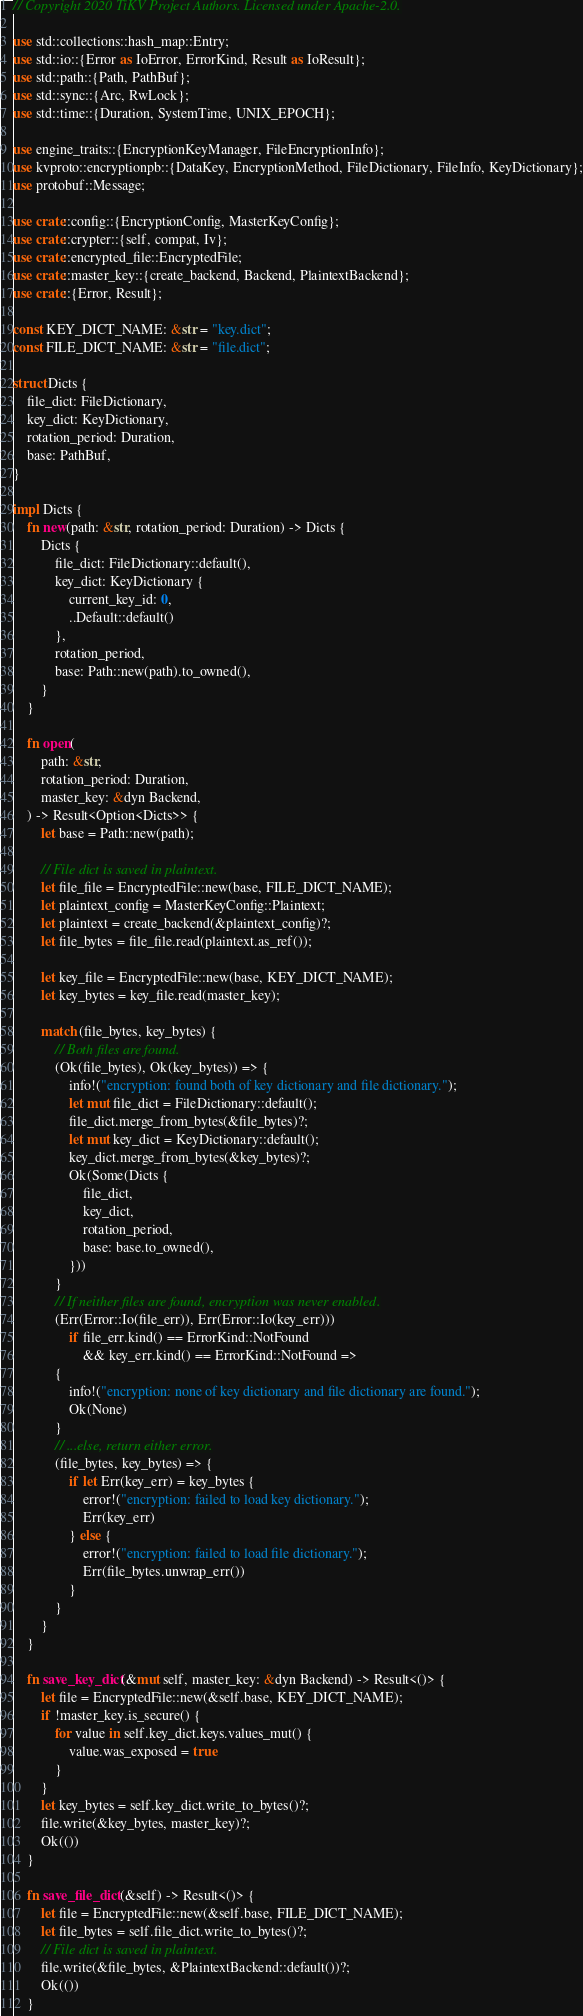Convert code to text. <code><loc_0><loc_0><loc_500><loc_500><_Rust_>// Copyright 2020 TiKV Project Authors. Licensed under Apache-2.0.

use std::collections::hash_map::Entry;
use std::io::{Error as IoError, ErrorKind, Result as IoResult};
use std::path::{Path, PathBuf};
use std::sync::{Arc, RwLock};
use std::time::{Duration, SystemTime, UNIX_EPOCH};

use engine_traits::{EncryptionKeyManager, FileEncryptionInfo};
use kvproto::encryptionpb::{DataKey, EncryptionMethod, FileDictionary, FileInfo, KeyDictionary};
use protobuf::Message;

use crate::config::{EncryptionConfig, MasterKeyConfig};
use crate::crypter::{self, compat, Iv};
use crate::encrypted_file::EncryptedFile;
use crate::master_key::{create_backend, Backend, PlaintextBackend};
use crate::{Error, Result};

const KEY_DICT_NAME: &str = "key.dict";
const FILE_DICT_NAME: &str = "file.dict";

struct Dicts {
    file_dict: FileDictionary,
    key_dict: KeyDictionary,
    rotation_period: Duration,
    base: PathBuf,
}

impl Dicts {
    fn new(path: &str, rotation_period: Duration) -> Dicts {
        Dicts {
            file_dict: FileDictionary::default(),
            key_dict: KeyDictionary {
                current_key_id: 0,
                ..Default::default()
            },
            rotation_period,
            base: Path::new(path).to_owned(),
        }
    }

    fn open(
        path: &str,
        rotation_period: Duration,
        master_key: &dyn Backend,
    ) -> Result<Option<Dicts>> {
        let base = Path::new(path);

        // File dict is saved in plaintext.
        let file_file = EncryptedFile::new(base, FILE_DICT_NAME);
        let plaintext_config = MasterKeyConfig::Plaintext;
        let plaintext = create_backend(&plaintext_config)?;
        let file_bytes = file_file.read(plaintext.as_ref());

        let key_file = EncryptedFile::new(base, KEY_DICT_NAME);
        let key_bytes = key_file.read(master_key);

        match (file_bytes, key_bytes) {
            // Both files are found.
            (Ok(file_bytes), Ok(key_bytes)) => {
                info!("encryption: found both of key dictionary and file dictionary.");
                let mut file_dict = FileDictionary::default();
                file_dict.merge_from_bytes(&file_bytes)?;
                let mut key_dict = KeyDictionary::default();
                key_dict.merge_from_bytes(&key_bytes)?;
                Ok(Some(Dicts {
                    file_dict,
                    key_dict,
                    rotation_period,
                    base: base.to_owned(),
                }))
            }
            // If neither files are found, encryption was never enabled.
            (Err(Error::Io(file_err)), Err(Error::Io(key_err)))
                if file_err.kind() == ErrorKind::NotFound
                    && key_err.kind() == ErrorKind::NotFound =>
            {
                info!("encryption: none of key dictionary and file dictionary are found.");
                Ok(None)
            }
            // ...else, return either error.
            (file_bytes, key_bytes) => {
                if let Err(key_err) = key_bytes {
                    error!("encryption: failed to load key dictionary.");
                    Err(key_err)
                } else {
                    error!("encryption: failed to load file dictionary.");
                    Err(file_bytes.unwrap_err())
                }
            }
        }
    }

    fn save_key_dict(&mut self, master_key: &dyn Backend) -> Result<()> {
        let file = EncryptedFile::new(&self.base, KEY_DICT_NAME);
        if !master_key.is_secure() {
            for value in self.key_dict.keys.values_mut() {
                value.was_exposed = true
            }
        }
        let key_bytes = self.key_dict.write_to_bytes()?;
        file.write(&key_bytes, master_key)?;
        Ok(())
    }

    fn save_file_dict(&self) -> Result<()> {
        let file = EncryptedFile::new(&self.base, FILE_DICT_NAME);
        let file_bytes = self.file_dict.write_to_bytes()?;
        // File dict is saved in plaintext.
        file.write(&file_bytes, &PlaintextBackend::default())?;
        Ok(())
    }
</code> 